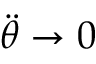Convert formula to latex. <formula><loc_0><loc_0><loc_500><loc_500>{ \ddot { \theta } } \to 0</formula> 